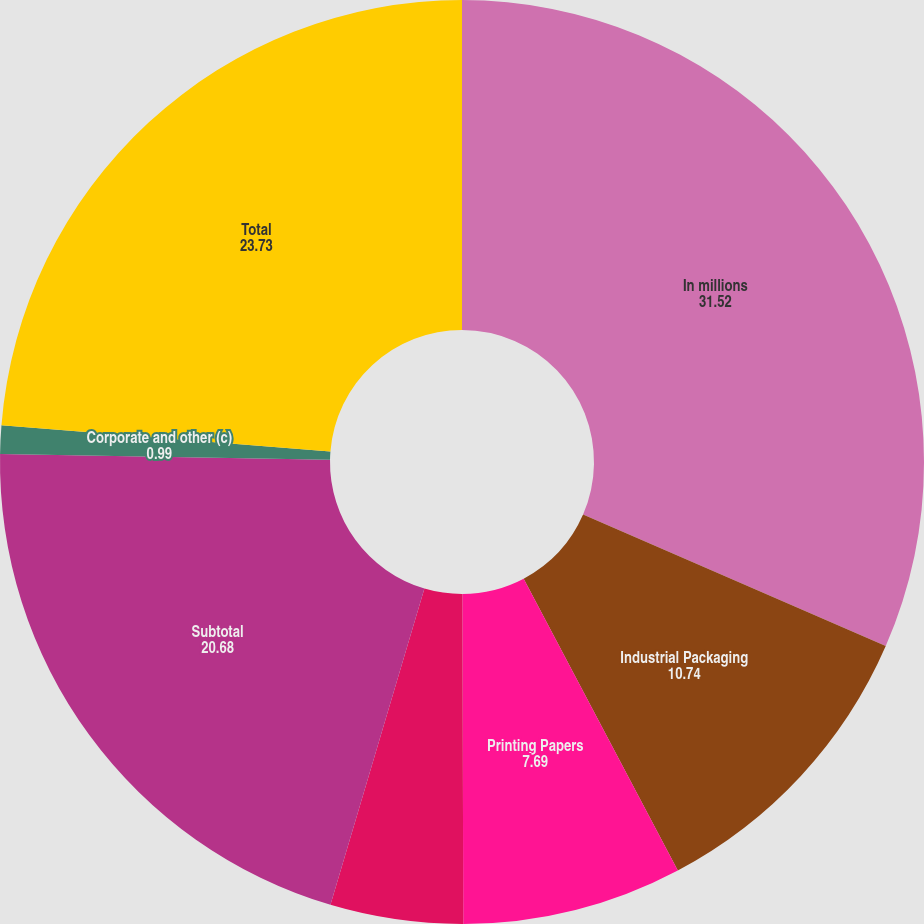<chart> <loc_0><loc_0><loc_500><loc_500><pie_chart><fcel>In millions<fcel>Industrial Packaging<fcel>Printing Papers<fcel>Consumer Packaging<fcel>Subtotal<fcel>Corporate and other (c)<fcel>Total<nl><fcel>31.52%<fcel>10.74%<fcel>7.69%<fcel>4.64%<fcel>20.68%<fcel>0.99%<fcel>23.73%<nl></chart> 